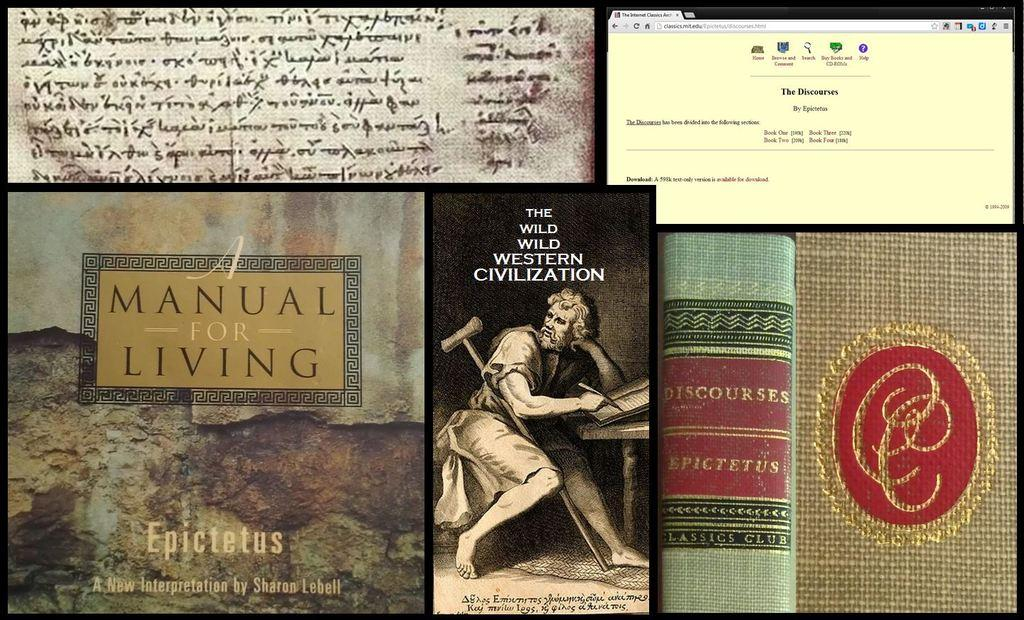<image>
Relay a brief, clear account of the picture shown. 3 books including A Manual for Living, along with a computer screen shot and handwritten text. 